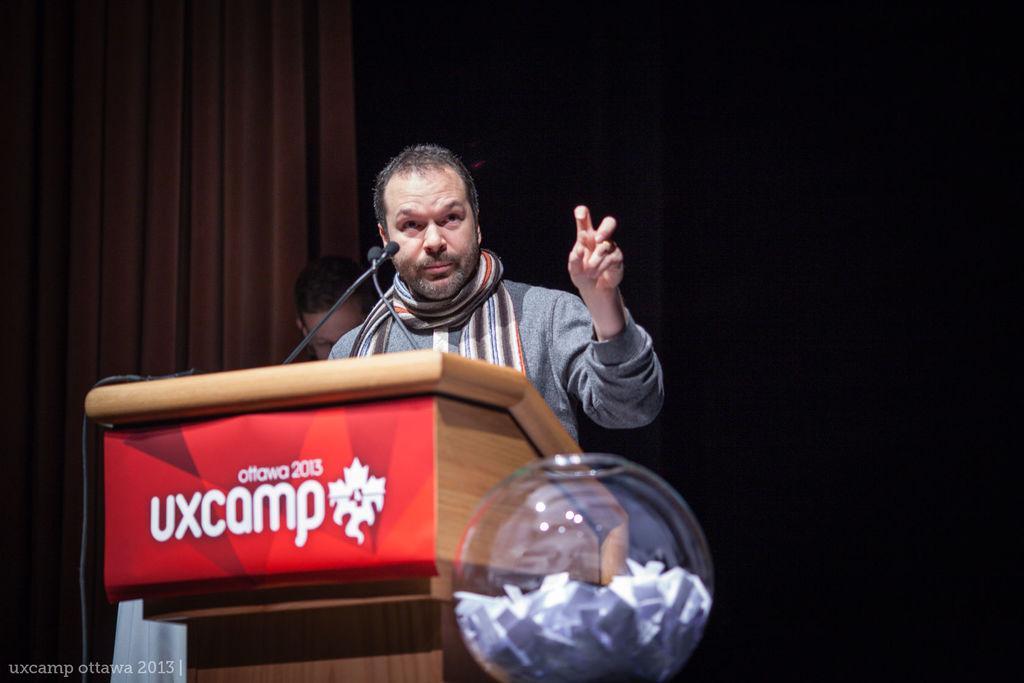How would you summarize this image in a sentence or two? In this image we can see two persons. One person is standing in front of a podium on which we can see microphones, cable and poster with some text. In the foreground we can see a bowl with some objects. In the background, we can see the curtains. At the bottom we can see some text. 